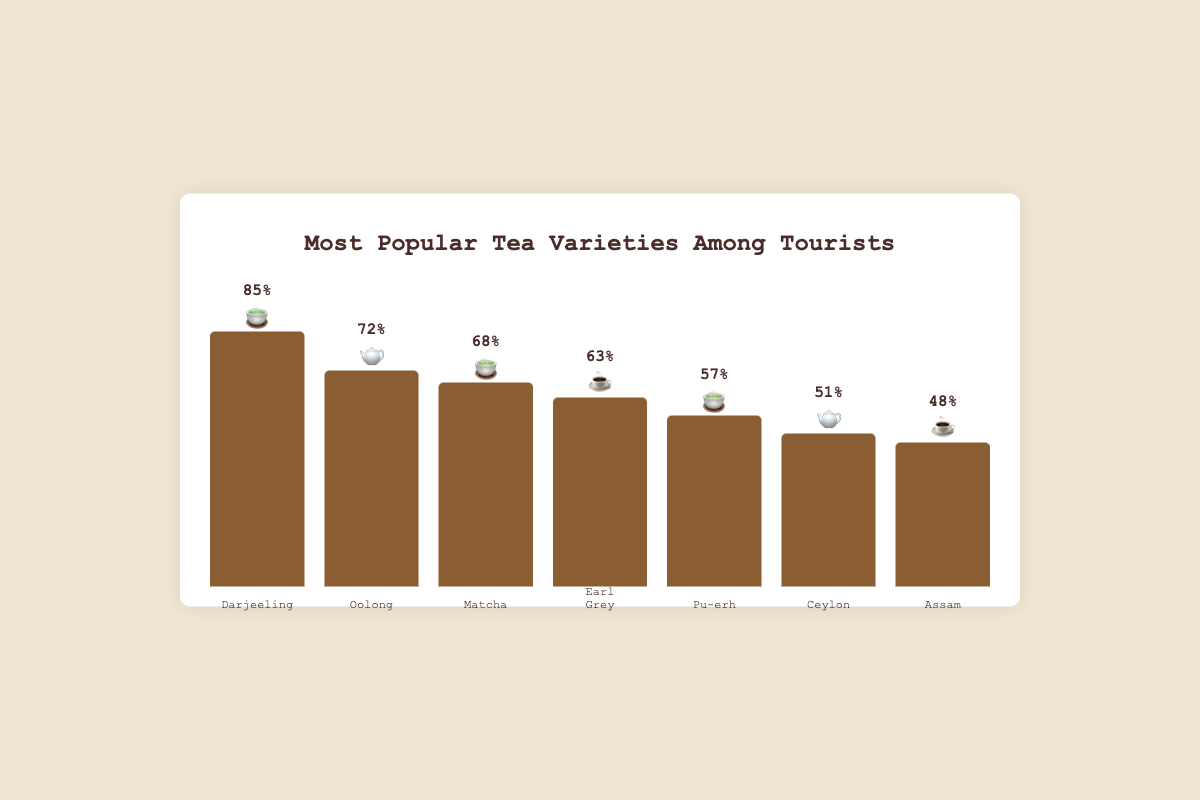Which tea variety is the most popular among tourists? The chart's tallest bar, representing 85% popularity, corresponds to Darjeeling, making it the most popular tea among tourists.
Answer: Darjeeling Which tea varieties have a popularity of at least 60%? By examining the bars with a height of 60% or greater, the tea varieties are Darjeeling (85%), Oolong (72%), Matcha (68%), and Earl Grey (63%).
Answer: Darjeeling, Oolong, Matcha, Earl Grey What is the popularity difference between the most and least popular tea varieties? Darjeeling is the most popular at 85%, and Assam is the least popular at 48%. The difference is 85 - 48 = 37%.
Answer: 37% Which tea varieties use the 🍵 emoji? By observing the emojis for each tea variety, the teas with the 🍵 emoji are Darjeeling, Matcha, and Pu-erh.
Answer: Darjeeling, Matcha, Pu-erh How does Oolong's popularity compare to Ceylon's popularity? Oolong has a popularity of 72%, whereas Ceylon has 51%. Therefore, Oolong is more popular than Ceylon.
Answer: Oolong is more popular What is the average popularity of the listed tea varieties? Summing the popularity percentages: 85 + 72 + 68 + 63 + 57 + 51 + 48 = 444. Dividing by the number of varieties (7) gives 444/7 ≈ 63.43%.
Answer: 63.43% Which tea varieties use the 🫖 emoji? The teas represented by the 🫖 emoji are Oolong and Ceylon, as indicated by the chart.
Answer: Oolong, Ceylon Which variety has the second highest popularity? The second tallest bar, indicating 72% popularity, represents Oolong.
Answer: Oolong Is the trend in the popularity percentages generally increasing or decreasing from left to right? From left to right, the bar heights generally decrease: Darjeeling (85%), Oolong (72%), Matcha (68%), Earl Grey (63%), Pu-erh (57%), Ceylon (51%), and Assam (48%).
Answer: Decreasing 